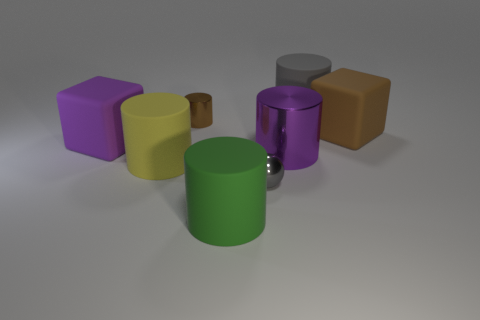Subtract all brown cylinders. How many cylinders are left? 4 Subtract all yellow cylinders. How many cylinders are left? 4 Subtract 2 cylinders. How many cylinders are left? 3 Add 1 big green matte objects. How many objects exist? 9 Subtract all blue cylinders. Subtract all cyan spheres. How many cylinders are left? 5 Subtract all blocks. How many objects are left? 6 Add 6 big blocks. How many big blocks are left? 8 Add 7 tiny green things. How many tiny green things exist? 7 Subtract 1 purple cubes. How many objects are left? 7 Subtract all small brown metal cubes. Subtract all gray metal balls. How many objects are left? 7 